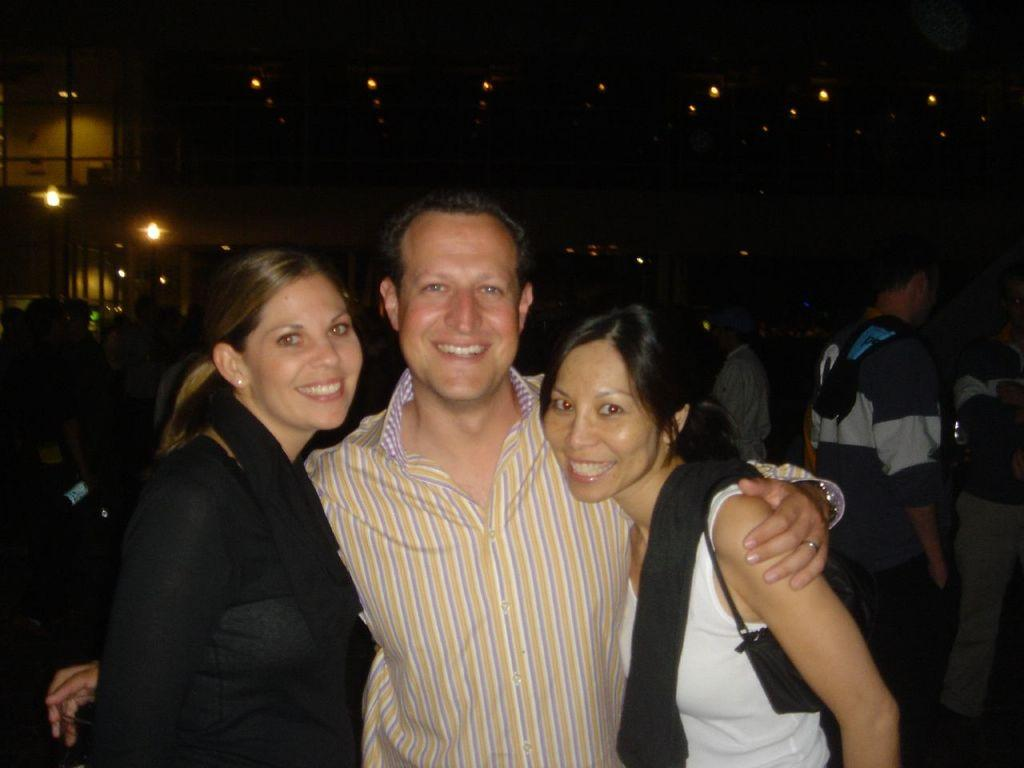What can be seen in the foreground of the image? There are people standing in the foreground of the image. What type of lighting is present on the left side of the image? There are pole lights on the left side of the image. What kind of lighting can be seen at the top of the image? There are lighting arrangements at the top of the image. How do the people in the image react to the sudden attack of a wild animal? There is no indication of an attack or a wild animal present in the image. The people are simply standing in the foreground. 